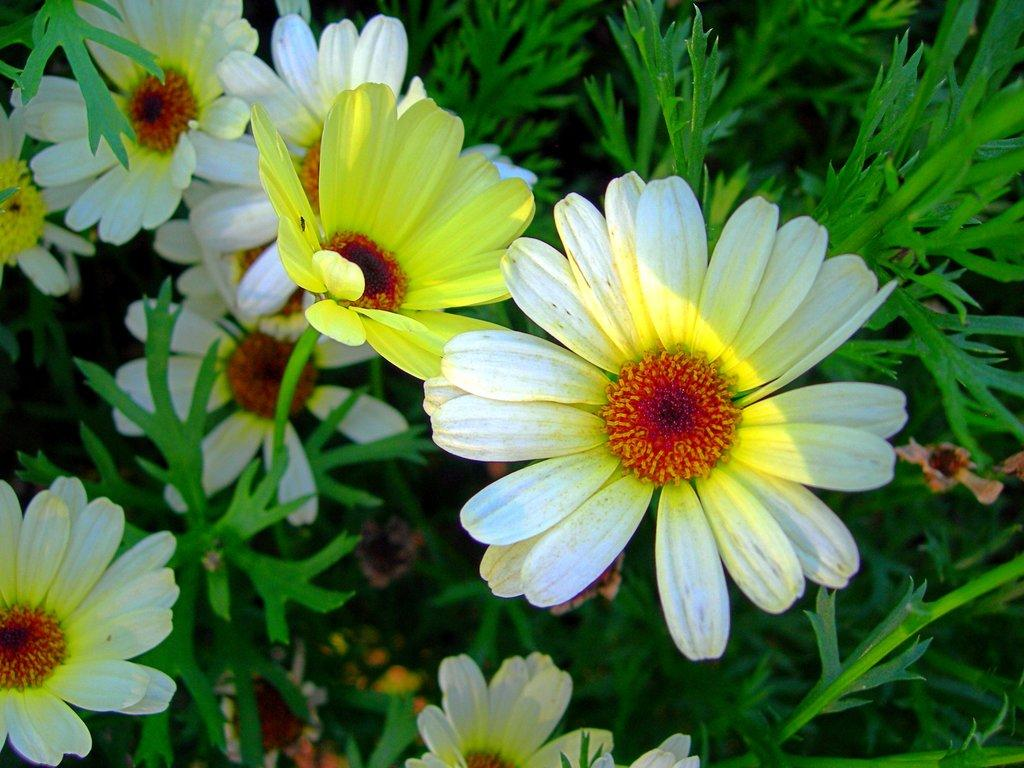What is the main subject in the center of the image? There are flowers in the center of the image. What color are the leaves associated with the flowers? The leaves in the image are green. Can you describe any other objects present in the image? Unfortunately, the provided facts do not specify any other objects present in the image. What type of fruit is being smashed by the rain in the image? There is no fruit or rain present in the image; it features flowers and green leaves. 